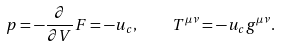Convert formula to latex. <formula><loc_0><loc_0><loc_500><loc_500>p = - \frac { \partial } { \partial V } F = - u _ { c } , \quad T ^ { \mu \nu } = - u _ { c } g ^ { \mu \nu } .</formula> 